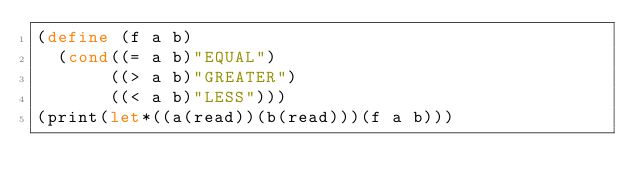<code> <loc_0><loc_0><loc_500><loc_500><_Scheme_>(define (f a b)
  (cond((= a b)"EQUAL")
       ((> a b)"GREATER")
       ((< a b)"LESS")))
(print(let*((a(read))(b(read)))(f a b)))</code> 